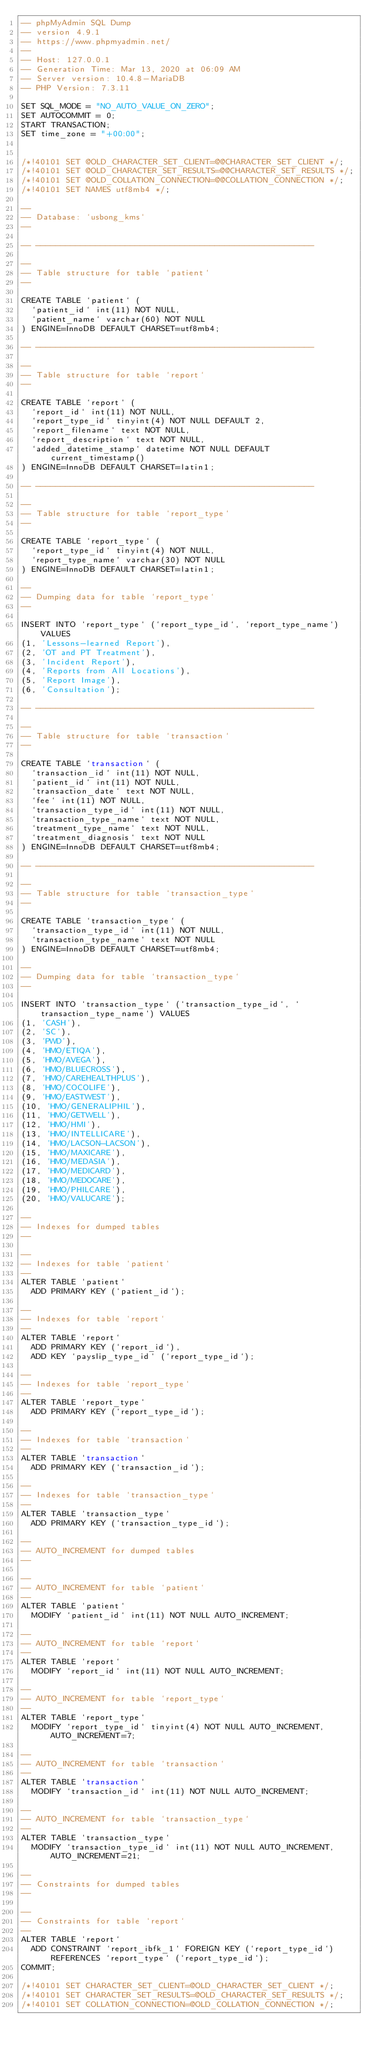<code> <loc_0><loc_0><loc_500><loc_500><_SQL_>-- phpMyAdmin SQL Dump
-- version 4.9.1
-- https://www.phpmyadmin.net/
--
-- Host: 127.0.0.1
-- Generation Time: Mar 13, 2020 at 06:09 AM
-- Server version: 10.4.8-MariaDB
-- PHP Version: 7.3.11

SET SQL_MODE = "NO_AUTO_VALUE_ON_ZERO";
SET AUTOCOMMIT = 0;
START TRANSACTION;
SET time_zone = "+00:00";


/*!40101 SET @OLD_CHARACTER_SET_CLIENT=@@CHARACTER_SET_CLIENT */;
/*!40101 SET @OLD_CHARACTER_SET_RESULTS=@@CHARACTER_SET_RESULTS */;
/*!40101 SET @OLD_COLLATION_CONNECTION=@@COLLATION_CONNECTION */;
/*!40101 SET NAMES utf8mb4 */;

--
-- Database: `usbong_kms`
--

-- --------------------------------------------------------

--
-- Table structure for table `patient`
--

CREATE TABLE `patient` (
  `patient_id` int(11) NOT NULL,
  `patient_name` varchar(60) NOT NULL
) ENGINE=InnoDB DEFAULT CHARSET=utf8mb4;

-- --------------------------------------------------------

--
-- Table structure for table `report`
--

CREATE TABLE `report` (
  `report_id` int(11) NOT NULL,
  `report_type_id` tinyint(4) NOT NULL DEFAULT 2,
  `report_filename` text NOT NULL,
  `report_description` text NOT NULL,
  `added_datetime_stamp` datetime NOT NULL DEFAULT current_timestamp()
) ENGINE=InnoDB DEFAULT CHARSET=latin1;

-- --------------------------------------------------------

--
-- Table structure for table `report_type`
--

CREATE TABLE `report_type` (
  `report_type_id` tinyint(4) NOT NULL,
  `report_type_name` varchar(30) NOT NULL
) ENGINE=InnoDB DEFAULT CHARSET=latin1;

--
-- Dumping data for table `report_type`
--

INSERT INTO `report_type` (`report_type_id`, `report_type_name`) VALUES
(1, 'Lessons-learned Report'),
(2, 'OT and PT Treatment'),
(3, 'Incident Report'),
(4, 'Reports from All Locations'),
(5, 'Report Image'),
(6, 'Consultation');

-- --------------------------------------------------------

--
-- Table structure for table `transaction`
--

CREATE TABLE `transaction` (
  `transaction_id` int(11) NOT NULL,
  `patient_id` int(11) NOT NULL,
  `transaction_date` text NOT NULL,
  `fee` int(11) NOT NULL,
  `transaction_type_id` int(11) NOT NULL,
  `transaction_type_name` text NOT NULL,
  `treatment_type_name` text NOT NULL,
  `treatment_diagnosis` text NOT NULL
) ENGINE=InnoDB DEFAULT CHARSET=utf8mb4;

-- --------------------------------------------------------

--
-- Table structure for table `transaction_type`
--

CREATE TABLE `transaction_type` (
  `transaction_type_id` int(11) NOT NULL,
  `transaction_type_name` text NOT NULL
) ENGINE=InnoDB DEFAULT CHARSET=utf8mb4;

--
-- Dumping data for table `transaction_type`
--

INSERT INTO `transaction_type` (`transaction_type_id`, `transaction_type_name`) VALUES
(1, 'CASH'),
(2, 'SC'),
(3, 'PWD'),
(4, 'HMO/ETIQA'),
(5, 'HMO/AVEGA'),
(6, 'HMO/BLUECROSS'),
(7, 'HMO/CAREHEALTHPLUS'),
(8, 'HMO/COCOLIFE'),
(9, 'HMO/EASTWEST'),
(10, 'HMO/GENERALIPHIL'),
(11, 'HMO/GETWELL'),
(12, 'HMO/HMI'),
(13, 'HMO/INTELLICARE'),
(14, 'HMO/LACSON-LACSON'),
(15, 'HMO/MAXICARE'),
(16, 'HMO/MEDASIA'),
(17, 'HMO/MEDICARD'),
(18, 'HMO/MEDOCARE'),
(19, 'HMO/PHILCARE'),
(20, 'HMO/VALUCARE');

--
-- Indexes for dumped tables
--

--
-- Indexes for table `patient`
--
ALTER TABLE `patient`
  ADD PRIMARY KEY (`patient_id`);

--
-- Indexes for table `report`
--
ALTER TABLE `report`
  ADD PRIMARY KEY (`report_id`),
  ADD KEY `payslip_type_id` (`report_type_id`);

--
-- Indexes for table `report_type`
--
ALTER TABLE `report_type`
  ADD PRIMARY KEY (`report_type_id`);

--
-- Indexes for table `transaction`
--
ALTER TABLE `transaction`
  ADD PRIMARY KEY (`transaction_id`);

--
-- Indexes for table `transaction_type`
--
ALTER TABLE `transaction_type`
  ADD PRIMARY KEY (`transaction_type_id`);

--
-- AUTO_INCREMENT for dumped tables
--

--
-- AUTO_INCREMENT for table `patient`
--
ALTER TABLE `patient`
  MODIFY `patient_id` int(11) NOT NULL AUTO_INCREMENT;

--
-- AUTO_INCREMENT for table `report`
--
ALTER TABLE `report`
  MODIFY `report_id` int(11) NOT NULL AUTO_INCREMENT;

--
-- AUTO_INCREMENT for table `report_type`
--
ALTER TABLE `report_type`
  MODIFY `report_type_id` tinyint(4) NOT NULL AUTO_INCREMENT, AUTO_INCREMENT=7;

--
-- AUTO_INCREMENT for table `transaction`
--
ALTER TABLE `transaction`
  MODIFY `transaction_id` int(11) NOT NULL AUTO_INCREMENT;

--
-- AUTO_INCREMENT for table `transaction_type`
--
ALTER TABLE `transaction_type`
  MODIFY `transaction_type_id` int(11) NOT NULL AUTO_INCREMENT, AUTO_INCREMENT=21;

--
-- Constraints for dumped tables
--

--
-- Constraints for table `report`
--
ALTER TABLE `report`
  ADD CONSTRAINT `report_ibfk_1` FOREIGN KEY (`report_type_id`) REFERENCES `report_type` (`report_type_id`);
COMMIT;

/*!40101 SET CHARACTER_SET_CLIENT=@OLD_CHARACTER_SET_CLIENT */;
/*!40101 SET CHARACTER_SET_RESULTS=@OLD_CHARACTER_SET_RESULTS */;
/*!40101 SET COLLATION_CONNECTION=@OLD_COLLATION_CONNECTION */;
</code> 